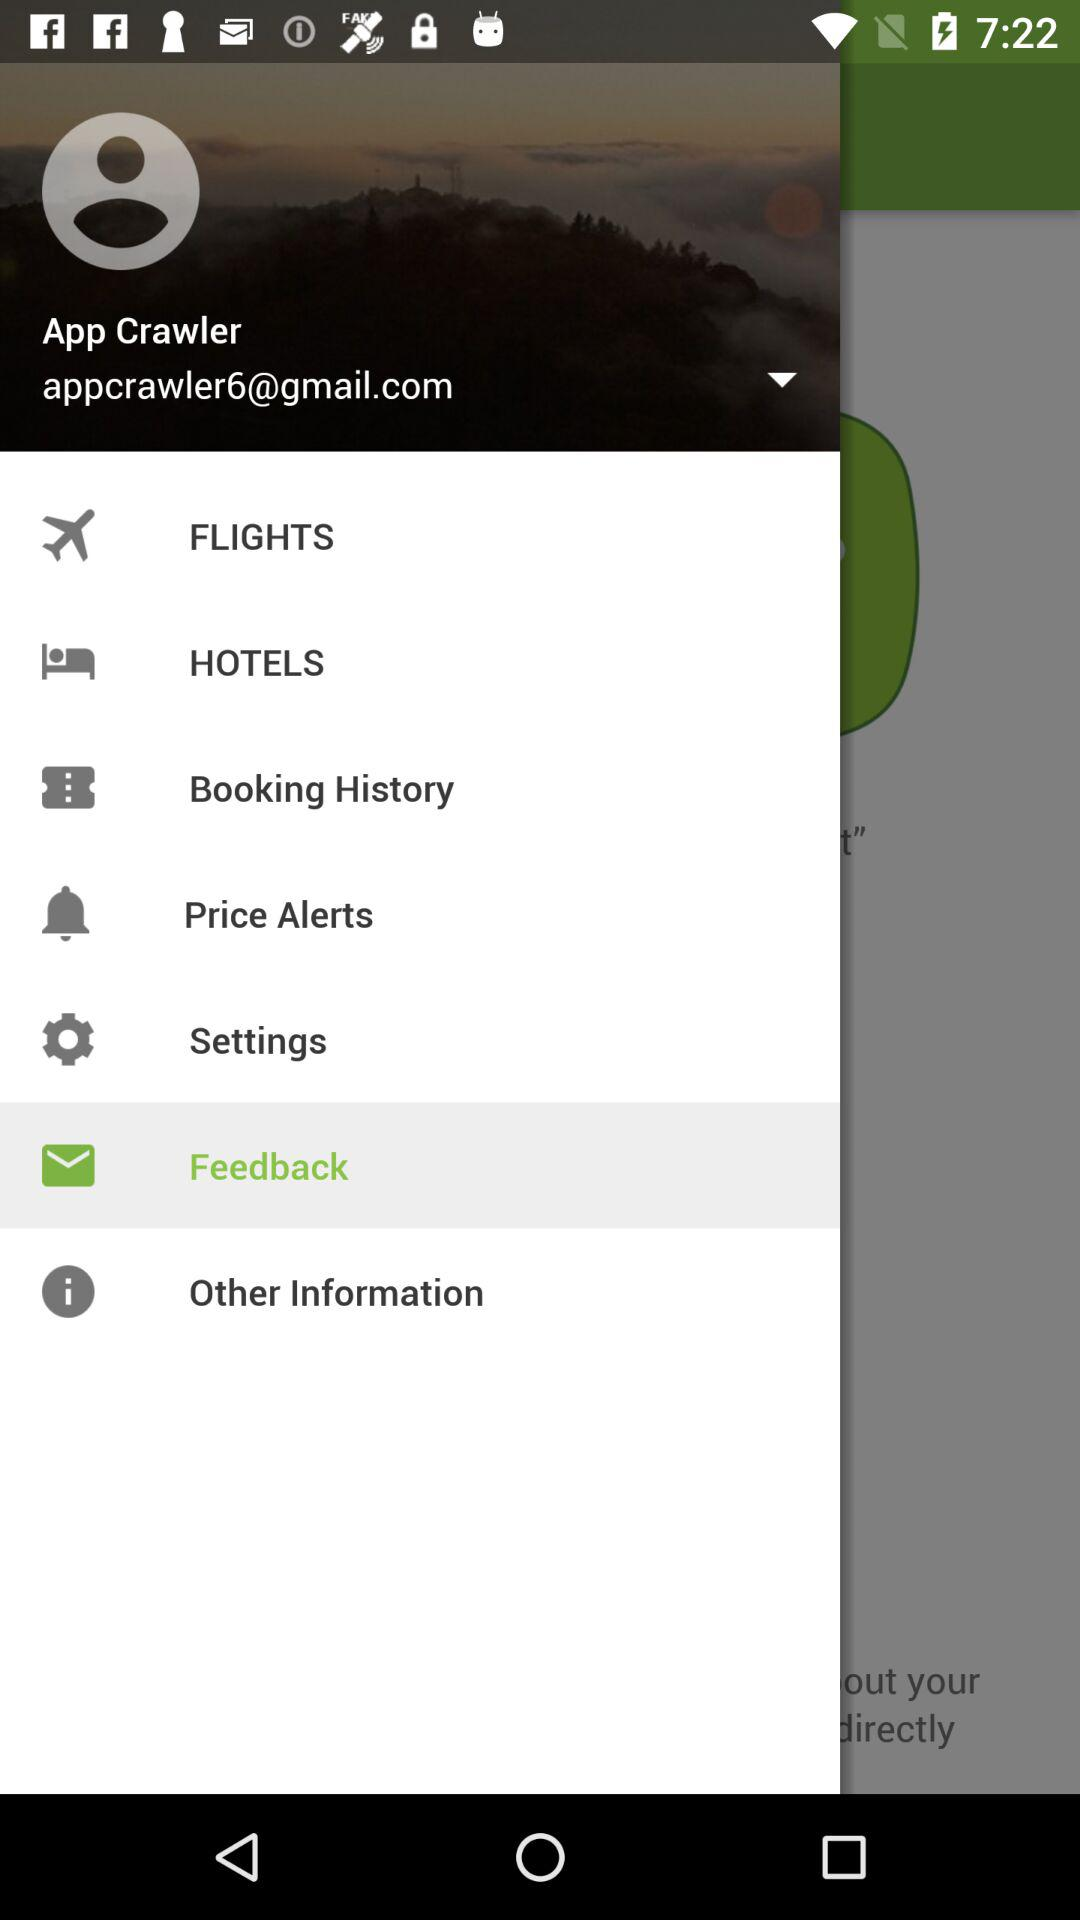What is the email address? The email address is appcrawler6@gmail.com. 